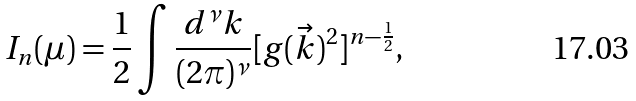Convert formula to latex. <formula><loc_0><loc_0><loc_500><loc_500>I _ { n } ( \mu ) = \frac { 1 } { 2 } \int \frac { d ^ { \nu } k } { ( 2 \pi ) ^ { \nu } } [ g ( \vec { k } ) ^ { 2 } ] ^ { n - \frac { 1 } { 2 } } ,</formula> 